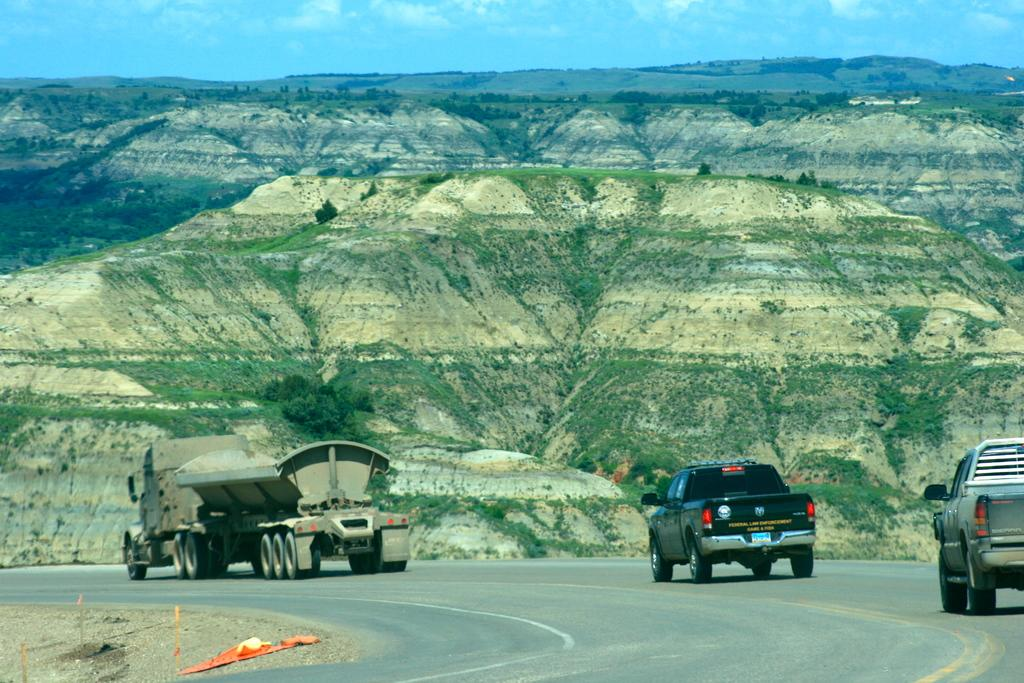What is happening on the road in the image? There are vehicles on the road in the image. What can be seen in the distance behind the vehicles? There are trees and hills in the background of the image. What type of frog can be seen practicing religion on the hills in the image? There is no frog or religious practice depicted in the image; it features vehicles on the road with trees and hills in the background. 